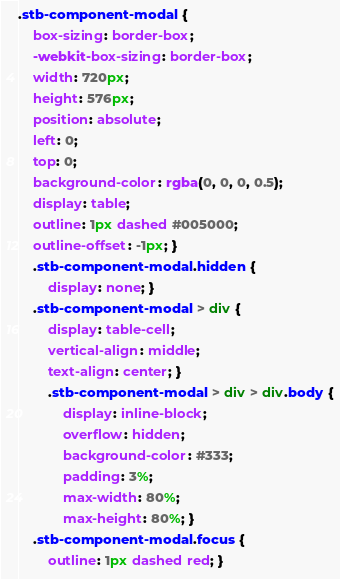<code> <loc_0><loc_0><loc_500><loc_500><_CSS_>.stb-component-modal {
    box-sizing: border-box;
    -webkit-box-sizing: border-box;
    width: 720px;
    height: 576px;
    position: absolute;
    left: 0;
    top: 0;
    background-color: rgba(0, 0, 0, 0.5);
    display: table;
    outline: 1px dashed #005000;
    outline-offset: -1px; }
    .stb-component-modal.hidden {
        display: none; }
    .stb-component-modal > div {
        display: table-cell;
        vertical-align: middle;
        text-align: center; }
        .stb-component-modal > div > div.body {
            display: inline-block;
            overflow: hidden;
            background-color: #333;
            padding: 3%;
            max-width: 80%;
            max-height: 80%; }
    .stb-component-modal.focus {
        outline: 1px dashed red; }
</code> 